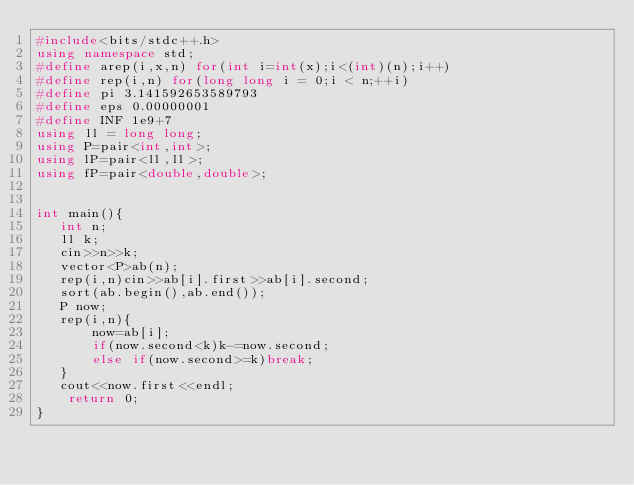<code> <loc_0><loc_0><loc_500><loc_500><_C++_>#include<bits/stdc++.h>
using namespace std;
#define arep(i,x,n) for(int i=int(x);i<(int)(n);i++)
#define rep(i,n) for(long long i = 0;i < n;++i)
#define pi 3.141592653589793
#define eps 0.00000001
#define INF 1e9+7  
using ll = long long; 
using P=pair<int,int>;
using lP=pair<ll,ll>;
using fP=pair<double,double>;


int main(){
   int n;
   ll k;
   cin>>n>>k;
   vector<P>ab(n);
   rep(i,n)cin>>ab[i].first>>ab[i].second;
   sort(ab.begin(),ab.end());
   P now;
   rep(i,n){
       now=ab[i];
       if(now.second<k)k-=now.second;
       else if(now.second>=k)break;
   }
   cout<<now.first<<endl;
    return 0;
}</code> 